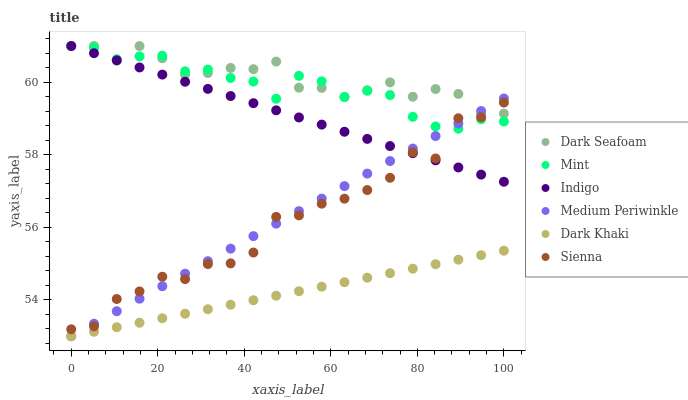Does Dark Khaki have the minimum area under the curve?
Answer yes or no. Yes. Does Dark Seafoam have the maximum area under the curve?
Answer yes or no. Yes. Does Indigo have the minimum area under the curve?
Answer yes or no. No. Does Indigo have the maximum area under the curve?
Answer yes or no. No. Is Dark Khaki the smoothest?
Answer yes or no. Yes. Is Sienna the roughest?
Answer yes or no. Yes. Is Indigo the smoothest?
Answer yes or no. No. Is Indigo the roughest?
Answer yes or no. No. Does Medium Periwinkle have the lowest value?
Answer yes or no. Yes. Does Indigo have the lowest value?
Answer yes or no. No. Does Mint have the highest value?
Answer yes or no. Yes. Does Medium Periwinkle have the highest value?
Answer yes or no. No. Is Dark Khaki less than Mint?
Answer yes or no. Yes. Is Indigo greater than Dark Khaki?
Answer yes or no. Yes. Does Dark Seafoam intersect Mint?
Answer yes or no. Yes. Is Dark Seafoam less than Mint?
Answer yes or no. No. Is Dark Seafoam greater than Mint?
Answer yes or no. No. Does Dark Khaki intersect Mint?
Answer yes or no. No. 